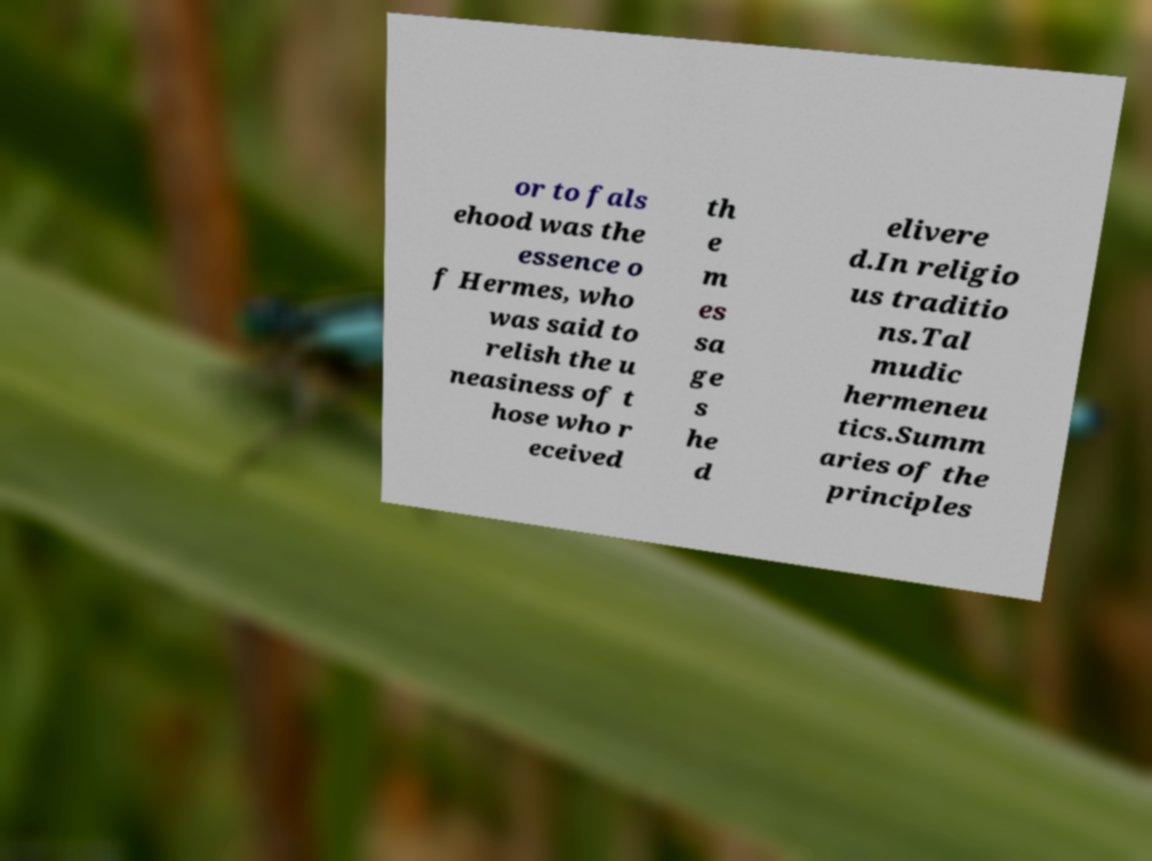I need the written content from this picture converted into text. Can you do that? or to fals ehood was the essence o f Hermes, who was said to relish the u neasiness of t hose who r eceived th e m es sa ge s he d elivere d.In religio us traditio ns.Tal mudic hermeneu tics.Summ aries of the principles 